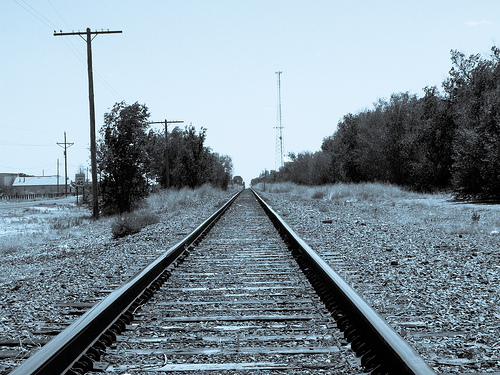<image>
Is there a track behind the tree? No. The track is not behind the tree. From this viewpoint, the track appears to be positioned elsewhere in the scene. 